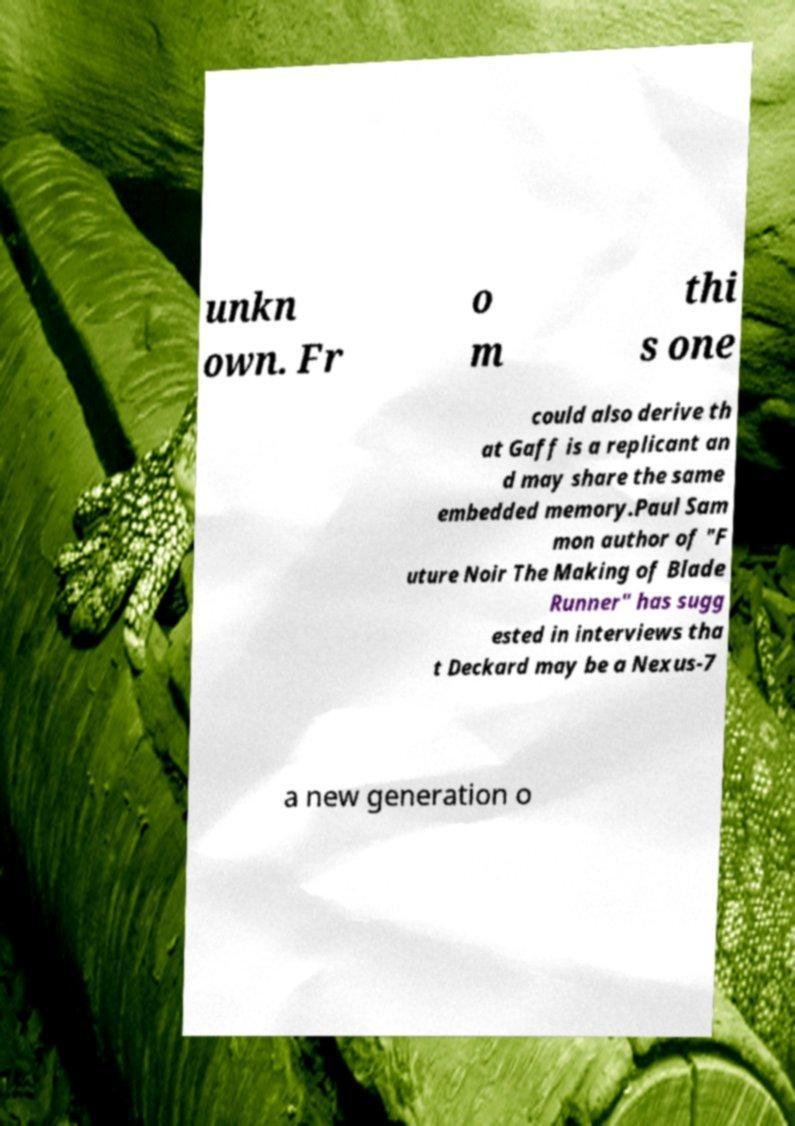Please identify and transcribe the text found in this image. unkn own. Fr o m thi s one could also derive th at Gaff is a replicant an d may share the same embedded memory.Paul Sam mon author of "F uture Noir The Making of Blade Runner" has sugg ested in interviews tha t Deckard may be a Nexus-7 a new generation o 